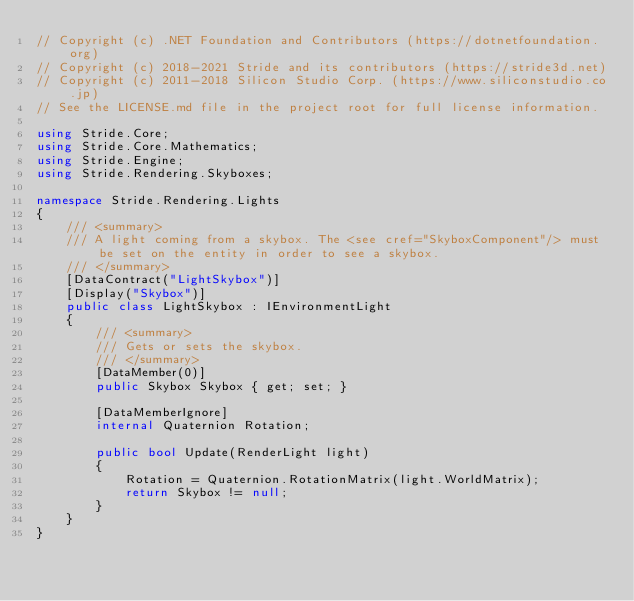Convert code to text. <code><loc_0><loc_0><loc_500><loc_500><_C#_>// Copyright (c) .NET Foundation and Contributors (https://dotnetfoundation.org)
// Copyright (c) 2018-2021 Stride and its contributors (https://stride3d.net)
// Copyright (c) 2011-2018 Silicon Studio Corp. (https://www.siliconstudio.co.jp)
// See the LICENSE.md file in the project root for full license information.

using Stride.Core;
using Stride.Core.Mathematics;
using Stride.Engine;
using Stride.Rendering.Skyboxes;

namespace Stride.Rendering.Lights
{
    /// <summary>
    /// A light coming from a skybox. The <see cref="SkyboxComponent"/> must be set on the entity in order to see a skybox. 
    /// </summary>
    [DataContract("LightSkybox")]
    [Display("Skybox")]
    public class LightSkybox : IEnvironmentLight
    {
        /// <summary>
        /// Gets or sets the skybox.
        /// </summary>
        [DataMember(0)]
        public Skybox Skybox { get; set; }

        [DataMemberIgnore]
        internal Quaternion Rotation;

        public bool Update(RenderLight light)
        {
            Rotation = Quaternion.RotationMatrix(light.WorldMatrix);
            return Skybox != null;
        }
    }
}
</code> 